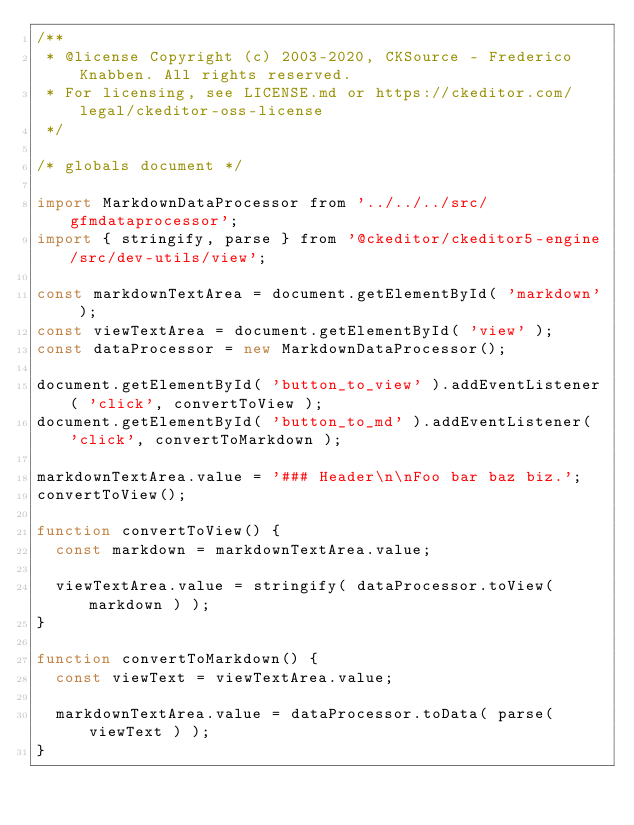Convert code to text. <code><loc_0><loc_0><loc_500><loc_500><_JavaScript_>/**
 * @license Copyright (c) 2003-2020, CKSource - Frederico Knabben. All rights reserved.
 * For licensing, see LICENSE.md or https://ckeditor.com/legal/ckeditor-oss-license
 */

/* globals document */

import MarkdownDataProcessor from '../../../src/gfmdataprocessor';
import { stringify, parse } from '@ckeditor/ckeditor5-engine/src/dev-utils/view';

const markdownTextArea = document.getElementById( 'markdown' );
const viewTextArea = document.getElementById( 'view' );
const dataProcessor = new MarkdownDataProcessor();

document.getElementById( 'button_to_view' ).addEventListener( 'click', convertToView );
document.getElementById( 'button_to_md' ).addEventListener( 'click', convertToMarkdown );

markdownTextArea.value = '### Header\n\nFoo bar baz biz.';
convertToView();

function convertToView() {
	const markdown = markdownTextArea.value;

	viewTextArea.value = stringify( dataProcessor.toView( markdown ) );
}

function convertToMarkdown() {
	const viewText = viewTextArea.value;

	markdownTextArea.value = dataProcessor.toData( parse( viewText ) );
}
</code> 